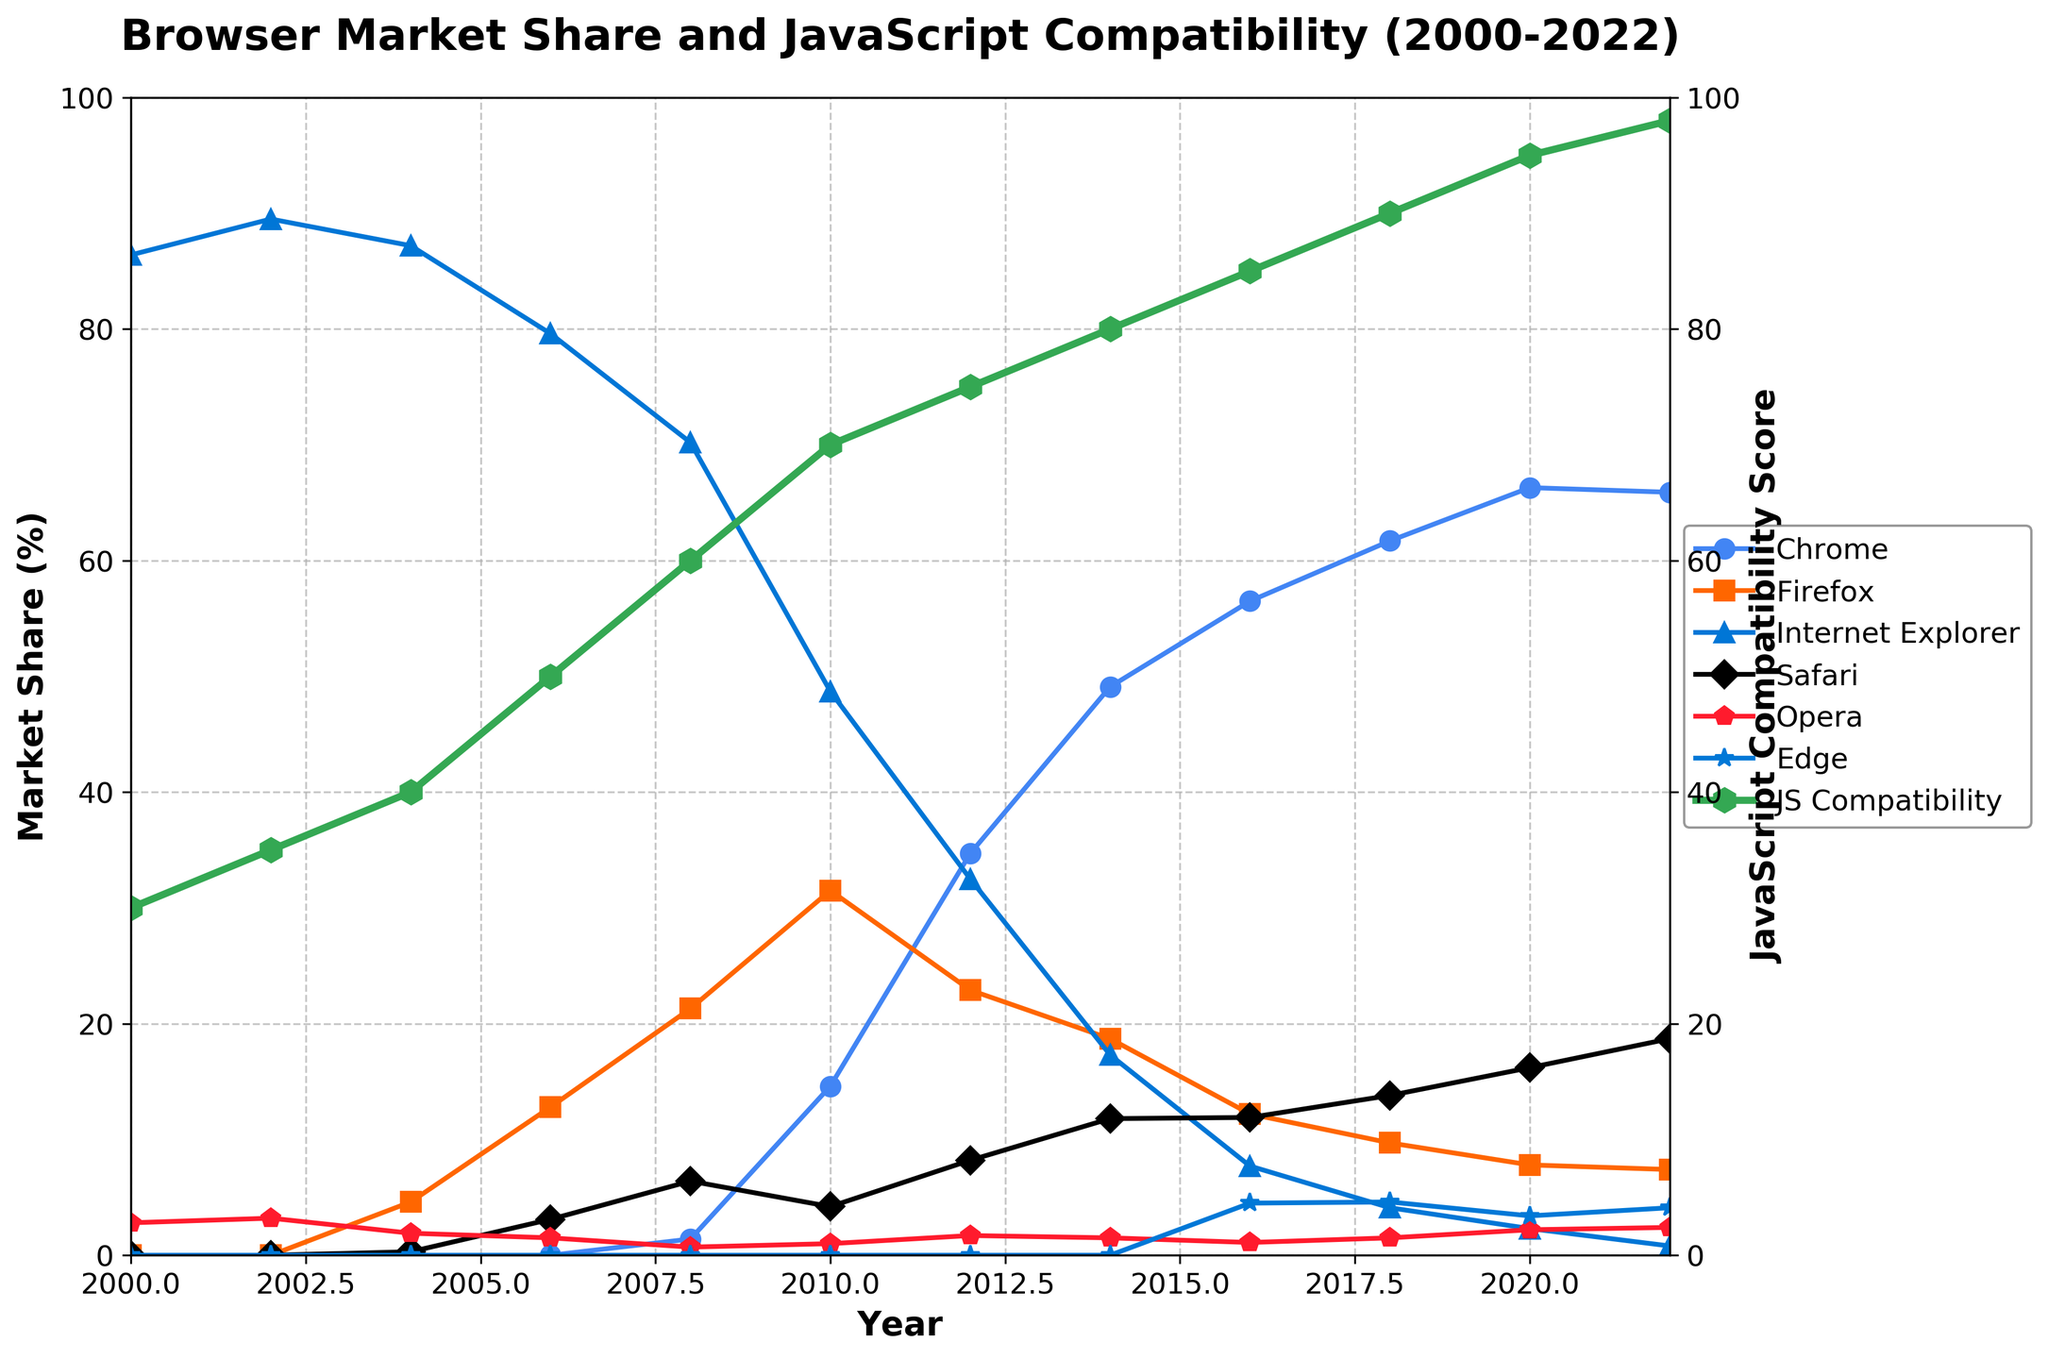Which year did Chrome exceed 50% market share? Examine the trend line for Chrome and identify the first year where the line rises above the 50% mark. This occurs around 2014.
Answer: 2014 Compare the market share of Firefox in 2006 and 2016. What is the difference? Locate the market share for Firefox in 2006 (12.8%) and 2016 (12.2%). Calculate the difference: 12.8% - 12.2% = 0.6%
Answer: 0.6% Which browser had the highest market share in 2000? Check the lines corresponding to different browsers in the year 2000. Internet Explorer has the highest market share (86.4%).
Answer: Internet Explorer How did the JavaScript Compatibility Score change between 2008 and 2012? Look at the JavaScript Compatibility Score for 2008 (60) and 2012 (75). Subtract the earlier value from the later: 75 - 60 = 15.
Answer: Increased by 15 What color represents the Safari browser in the plot? Identify the plot line associated with Safari and look at its color. Safari is represented by a black line.
Answer: Black In which year did Edge first appear with a non-zero market share? Check the plot lines and see in which year the Edge line first rises above 0. This happens in 2016 with 4.5%.
Answer: 2016 What is the average market share of Chrome from 2008 to 2022? Add up the market shares for Chrome from 2008 to 2022 and divide by the number of years (15): (1.4 + 14.6 + 34.7 + 49.1 + 56.5 + 61.7 + 66.3 + 65.9) / 11 = 34.0875. (Since there are only 11 data points within the range)
Answer: 34.1% Which year witnessed the highest JavaScript Compatibility Score? Find the year where the JavaScript Compatibility Score reaches its peak. This happens in 2022 with a score of 98.
Answer: 2022 Between 2004 and 2020, which browser saw the steepest decline in market share? Compare the slopes of decline for each browser between 2004 and 2020. Internet Explorer drops from 87.2% in 2004 to 2.3% in 2020, which is the steepest decline of 84.9%.
Answer: Internet Explorer Is the market share of Opera more stable than Firefox over the years? Compare the fluctuation and general trend lines of both Opera and Firefox. Opera shows smaller changes in its market share compared to the larger fluctuations in Firefox's market share from 4.6% to 31.5% then leveling off around 9.7%.
Answer: Yes 